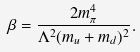<formula> <loc_0><loc_0><loc_500><loc_500>\beta = \frac { 2 m ^ { 4 } _ { \pi } } { \Lambda ^ { 2 } ( m _ { u } + m _ { d } ) ^ { 2 } } .</formula> 